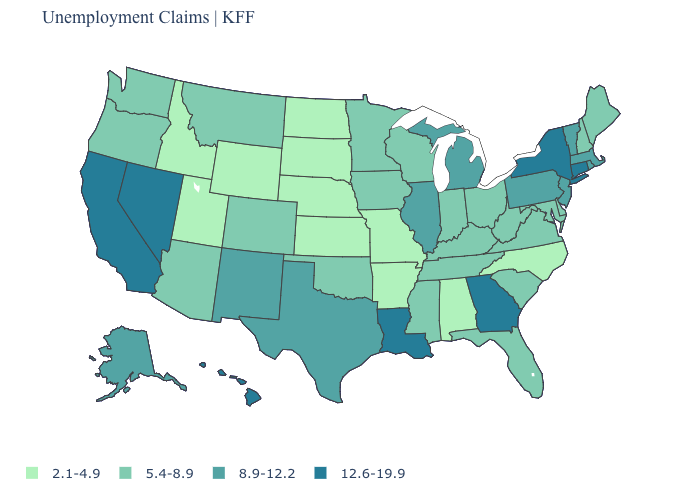Which states have the highest value in the USA?
Short answer required. California, Connecticut, Georgia, Hawaii, Louisiana, Nevada, New York. What is the highest value in states that border Ohio?
Be succinct. 8.9-12.2. What is the value of Arkansas?
Answer briefly. 2.1-4.9. What is the value of Vermont?
Answer briefly. 8.9-12.2. Name the states that have a value in the range 2.1-4.9?
Answer briefly. Alabama, Arkansas, Idaho, Kansas, Missouri, Nebraska, North Carolina, North Dakota, South Dakota, Utah, Wyoming. What is the highest value in the USA?
Quick response, please. 12.6-19.9. Name the states that have a value in the range 2.1-4.9?
Answer briefly. Alabama, Arkansas, Idaho, Kansas, Missouri, Nebraska, North Carolina, North Dakota, South Dakota, Utah, Wyoming. What is the lowest value in the MidWest?
Keep it brief. 2.1-4.9. Among the states that border Ohio , does Michigan have the highest value?
Give a very brief answer. Yes. Is the legend a continuous bar?
Quick response, please. No. What is the lowest value in the USA?
Keep it brief. 2.1-4.9. What is the value of Alaska?
Concise answer only. 8.9-12.2. Does Massachusetts have the lowest value in the Northeast?
Give a very brief answer. No. Is the legend a continuous bar?
Give a very brief answer. No. Does the map have missing data?
Answer briefly. No. 